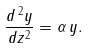<formula> <loc_0><loc_0><loc_500><loc_500>\frac { d \, ^ { 2 } y } { d z ^ { 2 } } = \alpha \, y .</formula> 